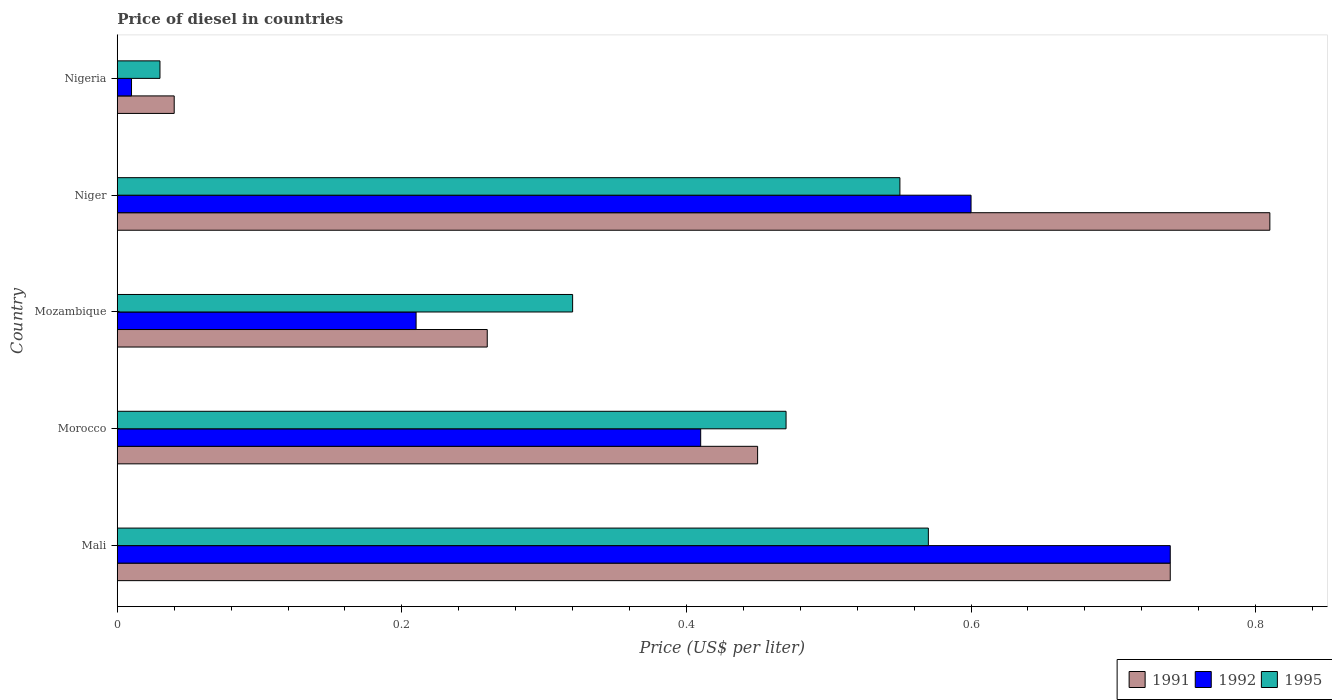How many different coloured bars are there?
Keep it short and to the point. 3. How many groups of bars are there?
Ensure brevity in your answer.  5. Are the number of bars per tick equal to the number of legend labels?
Give a very brief answer. Yes. How many bars are there on the 4th tick from the top?
Keep it short and to the point. 3. How many bars are there on the 4th tick from the bottom?
Keep it short and to the point. 3. What is the label of the 4th group of bars from the top?
Your response must be concise. Morocco. In how many cases, is the number of bars for a given country not equal to the number of legend labels?
Provide a succinct answer. 0. What is the price of diesel in 1992 in Niger?
Make the answer very short. 0.6. Across all countries, what is the maximum price of diesel in 1992?
Keep it short and to the point. 0.74. Across all countries, what is the minimum price of diesel in 1992?
Your answer should be very brief. 0.01. In which country was the price of diesel in 1991 maximum?
Your response must be concise. Niger. In which country was the price of diesel in 1995 minimum?
Offer a very short reply. Nigeria. What is the total price of diesel in 1995 in the graph?
Keep it short and to the point. 1.94. What is the difference between the price of diesel in 1991 in Mali and that in Mozambique?
Give a very brief answer. 0.48. What is the difference between the price of diesel in 1995 in Mozambique and the price of diesel in 1992 in Mali?
Keep it short and to the point. -0.42. What is the average price of diesel in 1992 per country?
Your answer should be compact. 0.39. What is the difference between the price of diesel in 1991 and price of diesel in 1995 in Morocco?
Offer a terse response. -0.02. What is the ratio of the price of diesel in 1991 in Morocco to that in Nigeria?
Keep it short and to the point. 11.25. Is the price of diesel in 1992 in Mali less than that in Morocco?
Keep it short and to the point. No. Is the difference between the price of diesel in 1991 in Mali and Mozambique greater than the difference between the price of diesel in 1995 in Mali and Mozambique?
Your response must be concise. Yes. What is the difference between the highest and the second highest price of diesel in 1991?
Your response must be concise. 0.07. What is the difference between the highest and the lowest price of diesel in 1991?
Provide a short and direct response. 0.77. Is the sum of the price of diesel in 1992 in Mozambique and Nigeria greater than the maximum price of diesel in 1991 across all countries?
Keep it short and to the point. No. What does the 3rd bar from the top in Mozambique represents?
Keep it short and to the point. 1991. Are all the bars in the graph horizontal?
Make the answer very short. Yes. How many countries are there in the graph?
Your answer should be compact. 5. Does the graph contain grids?
Keep it short and to the point. No. Where does the legend appear in the graph?
Keep it short and to the point. Bottom right. How many legend labels are there?
Provide a succinct answer. 3. What is the title of the graph?
Offer a very short reply. Price of diesel in countries. Does "1972" appear as one of the legend labels in the graph?
Your response must be concise. No. What is the label or title of the X-axis?
Offer a very short reply. Price (US$ per liter). What is the Price (US$ per liter) in 1991 in Mali?
Give a very brief answer. 0.74. What is the Price (US$ per liter) in 1992 in Mali?
Your answer should be very brief. 0.74. What is the Price (US$ per liter) of 1995 in Mali?
Your response must be concise. 0.57. What is the Price (US$ per liter) in 1991 in Morocco?
Ensure brevity in your answer.  0.45. What is the Price (US$ per liter) of 1992 in Morocco?
Give a very brief answer. 0.41. What is the Price (US$ per liter) in 1995 in Morocco?
Offer a terse response. 0.47. What is the Price (US$ per liter) in 1991 in Mozambique?
Offer a very short reply. 0.26. What is the Price (US$ per liter) in 1992 in Mozambique?
Your answer should be compact. 0.21. What is the Price (US$ per liter) in 1995 in Mozambique?
Give a very brief answer. 0.32. What is the Price (US$ per liter) of 1991 in Niger?
Make the answer very short. 0.81. What is the Price (US$ per liter) in 1995 in Niger?
Provide a short and direct response. 0.55. What is the Price (US$ per liter) in 1992 in Nigeria?
Your answer should be compact. 0.01. What is the Price (US$ per liter) of 1995 in Nigeria?
Your answer should be compact. 0.03. Across all countries, what is the maximum Price (US$ per liter) in 1991?
Keep it short and to the point. 0.81. Across all countries, what is the maximum Price (US$ per liter) of 1992?
Give a very brief answer. 0.74. Across all countries, what is the maximum Price (US$ per liter) in 1995?
Give a very brief answer. 0.57. Across all countries, what is the minimum Price (US$ per liter) of 1995?
Keep it short and to the point. 0.03. What is the total Price (US$ per liter) in 1991 in the graph?
Your answer should be very brief. 2.3. What is the total Price (US$ per liter) of 1992 in the graph?
Keep it short and to the point. 1.97. What is the total Price (US$ per liter) of 1995 in the graph?
Your response must be concise. 1.94. What is the difference between the Price (US$ per liter) of 1991 in Mali and that in Morocco?
Provide a succinct answer. 0.29. What is the difference between the Price (US$ per liter) in 1992 in Mali and that in Morocco?
Provide a succinct answer. 0.33. What is the difference between the Price (US$ per liter) of 1995 in Mali and that in Morocco?
Offer a terse response. 0.1. What is the difference between the Price (US$ per liter) of 1991 in Mali and that in Mozambique?
Offer a terse response. 0.48. What is the difference between the Price (US$ per liter) of 1992 in Mali and that in Mozambique?
Your answer should be very brief. 0.53. What is the difference between the Price (US$ per liter) of 1995 in Mali and that in Mozambique?
Provide a succinct answer. 0.25. What is the difference between the Price (US$ per liter) of 1991 in Mali and that in Niger?
Ensure brevity in your answer.  -0.07. What is the difference between the Price (US$ per liter) in 1992 in Mali and that in Niger?
Provide a short and direct response. 0.14. What is the difference between the Price (US$ per liter) in 1995 in Mali and that in Niger?
Offer a very short reply. 0.02. What is the difference between the Price (US$ per liter) in 1992 in Mali and that in Nigeria?
Keep it short and to the point. 0.73. What is the difference between the Price (US$ per liter) of 1995 in Mali and that in Nigeria?
Give a very brief answer. 0.54. What is the difference between the Price (US$ per liter) of 1991 in Morocco and that in Mozambique?
Your answer should be compact. 0.19. What is the difference between the Price (US$ per liter) in 1992 in Morocco and that in Mozambique?
Ensure brevity in your answer.  0.2. What is the difference between the Price (US$ per liter) in 1995 in Morocco and that in Mozambique?
Ensure brevity in your answer.  0.15. What is the difference between the Price (US$ per liter) of 1991 in Morocco and that in Niger?
Provide a succinct answer. -0.36. What is the difference between the Price (US$ per liter) of 1992 in Morocco and that in Niger?
Your response must be concise. -0.19. What is the difference between the Price (US$ per liter) in 1995 in Morocco and that in Niger?
Give a very brief answer. -0.08. What is the difference between the Price (US$ per liter) in 1991 in Morocco and that in Nigeria?
Keep it short and to the point. 0.41. What is the difference between the Price (US$ per liter) in 1992 in Morocco and that in Nigeria?
Offer a very short reply. 0.4. What is the difference between the Price (US$ per liter) of 1995 in Morocco and that in Nigeria?
Offer a terse response. 0.44. What is the difference between the Price (US$ per liter) in 1991 in Mozambique and that in Niger?
Ensure brevity in your answer.  -0.55. What is the difference between the Price (US$ per liter) of 1992 in Mozambique and that in Niger?
Offer a very short reply. -0.39. What is the difference between the Price (US$ per liter) of 1995 in Mozambique and that in Niger?
Your response must be concise. -0.23. What is the difference between the Price (US$ per liter) of 1991 in Mozambique and that in Nigeria?
Give a very brief answer. 0.22. What is the difference between the Price (US$ per liter) in 1995 in Mozambique and that in Nigeria?
Make the answer very short. 0.29. What is the difference between the Price (US$ per liter) of 1991 in Niger and that in Nigeria?
Give a very brief answer. 0.77. What is the difference between the Price (US$ per liter) of 1992 in Niger and that in Nigeria?
Your answer should be very brief. 0.59. What is the difference between the Price (US$ per liter) in 1995 in Niger and that in Nigeria?
Make the answer very short. 0.52. What is the difference between the Price (US$ per liter) of 1991 in Mali and the Price (US$ per liter) of 1992 in Morocco?
Provide a short and direct response. 0.33. What is the difference between the Price (US$ per liter) of 1991 in Mali and the Price (US$ per liter) of 1995 in Morocco?
Your answer should be compact. 0.27. What is the difference between the Price (US$ per liter) of 1992 in Mali and the Price (US$ per liter) of 1995 in Morocco?
Give a very brief answer. 0.27. What is the difference between the Price (US$ per liter) in 1991 in Mali and the Price (US$ per liter) in 1992 in Mozambique?
Your answer should be compact. 0.53. What is the difference between the Price (US$ per liter) of 1991 in Mali and the Price (US$ per liter) of 1995 in Mozambique?
Give a very brief answer. 0.42. What is the difference between the Price (US$ per liter) of 1992 in Mali and the Price (US$ per liter) of 1995 in Mozambique?
Keep it short and to the point. 0.42. What is the difference between the Price (US$ per liter) in 1991 in Mali and the Price (US$ per liter) in 1992 in Niger?
Give a very brief answer. 0.14. What is the difference between the Price (US$ per liter) in 1991 in Mali and the Price (US$ per liter) in 1995 in Niger?
Provide a short and direct response. 0.19. What is the difference between the Price (US$ per liter) of 1992 in Mali and the Price (US$ per liter) of 1995 in Niger?
Your answer should be very brief. 0.19. What is the difference between the Price (US$ per liter) of 1991 in Mali and the Price (US$ per liter) of 1992 in Nigeria?
Keep it short and to the point. 0.73. What is the difference between the Price (US$ per liter) in 1991 in Mali and the Price (US$ per liter) in 1995 in Nigeria?
Offer a very short reply. 0.71. What is the difference between the Price (US$ per liter) in 1992 in Mali and the Price (US$ per liter) in 1995 in Nigeria?
Offer a terse response. 0.71. What is the difference between the Price (US$ per liter) of 1991 in Morocco and the Price (US$ per liter) of 1992 in Mozambique?
Provide a short and direct response. 0.24. What is the difference between the Price (US$ per liter) of 1991 in Morocco and the Price (US$ per liter) of 1995 in Mozambique?
Ensure brevity in your answer.  0.13. What is the difference between the Price (US$ per liter) in 1992 in Morocco and the Price (US$ per liter) in 1995 in Mozambique?
Make the answer very short. 0.09. What is the difference between the Price (US$ per liter) in 1992 in Morocco and the Price (US$ per liter) in 1995 in Niger?
Ensure brevity in your answer.  -0.14. What is the difference between the Price (US$ per liter) in 1991 in Morocco and the Price (US$ per liter) in 1992 in Nigeria?
Offer a terse response. 0.44. What is the difference between the Price (US$ per liter) of 1991 in Morocco and the Price (US$ per liter) of 1995 in Nigeria?
Provide a short and direct response. 0.42. What is the difference between the Price (US$ per liter) of 1992 in Morocco and the Price (US$ per liter) of 1995 in Nigeria?
Offer a very short reply. 0.38. What is the difference between the Price (US$ per liter) in 1991 in Mozambique and the Price (US$ per liter) in 1992 in Niger?
Keep it short and to the point. -0.34. What is the difference between the Price (US$ per liter) in 1991 in Mozambique and the Price (US$ per liter) in 1995 in Niger?
Your answer should be very brief. -0.29. What is the difference between the Price (US$ per liter) in 1992 in Mozambique and the Price (US$ per liter) in 1995 in Niger?
Provide a short and direct response. -0.34. What is the difference between the Price (US$ per liter) of 1991 in Mozambique and the Price (US$ per liter) of 1995 in Nigeria?
Your answer should be compact. 0.23. What is the difference between the Price (US$ per liter) of 1992 in Mozambique and the Price (US$ per liter) of 1995 in Nigeria?
Your answer should be very brief. 0.18. What is the difference between the Price (US$ per liter) in 1991 in Niger and the Price (US$ per liter) in 1995 in Nigeria?
Make the answer very short. 0.78. What is the difference between the Price (US$ per liter) of 1992 in Niger and the Price (US$ per liter) of 1995 in Nigeria?
Make the answer very short. 0.57. What is the average Price (US$ per liter) of 1991 per country?
Your answer should be very brief. 0.46. What is the average Price (US$ per liter) in 1992 per country?
Your response must be concise. 0.39. What is the average Price (US$ per liter) of 1995 per country?
Your answer should be very brief. 0.39. What is the difference between the Price (US$ per liter) in 1991 and Price (US$ per liter) in 1992 in Mali?
Offer a terse response. 0. What is the difference between the Price (US$ per liter) of 1991 and Price (US$ per liter) of 1995 in Mali?
Give a very brief answer. 0.17. What is the difference between the Price (US$ per liter) of 1992 and Price (US$ per liter) of 1995 in Mali?
Provide a succinct answer. 0.17. What is the difference between the Price (US$ per liter) of 1991 and Price (US$ per liter) of 1992 in Morocco?
Provide a succinct answer. 0.04. What is the difference between the Price (US$ per liter) in 1991 and Price (US$ per liter) in 1995 in Morocco?
Provide a succinct answer. -0.02. What is the difference between the Price (US$ per liter) of 1992 and Price (US$ per liter) of 1995 in Morocco?
Provide a short and direct response. -0.06. What is the difference between the Price (US$ per liter) of 1991 and Price (US$ per liter) of 1995 in Mozambique?
Your response must be concise. -0.06. What is the difference between the Price (US$ per liter) of 1992 and Price (US$ per liter) of 1995 in Mozambique?
Provide a short and direct response. -0.11. What is the difference between the Price (US$ per liter) of 1991 and Price (US$ per liter) of 1992 in Niger?
Offer a terse response. 0.21. What is the difference between the Price (US$ per liter) in 1991 and Price (US$ per liter) in 1995 in Niger?
Your answer should be compact. 0.26. What is the difference between the Price (US$ per liter) of 1992 and Price (US$ per liter) of 1995 in Niger?
Offer a very short reply. 0.05. What is the difference between the Price (US$ per liter) in 1991 and Price (US$ per liter) in 1995 in Nigeria?
Give a very brief answer. 0.01. What is the difference between the Price (US$ per liter) in 1992 and Price (US$ per liter) in 1995 in Nigeria?
Provide a short and direct response. -0.02. What is the ratio of the Price (US$ per liter) of 1991 in Mali to that in Morocco?
Ensure brevity in your answer.  1.64. What is the ratio of the Price (US$ per liter) of 1992 in Mali to that in Morocco?
Your answer should be compact. 1.8. What is the ratio of the Price (US$ per liter) of 1995 in Mali to that in Morocco?
Offer a very short reply. 1.21. What is the ratio of the Price (US$ per liter) in 1991 in Mali to that in Mozambique?
Offer a terse response. 2.85. What is the ratio of the Price (US$ per liter) in 1992 in Mali to that in Mozambique?
Your answer should be compact. 3.52. What is the ratio of the Price (US$ per liter) of 1995 in Mali to that in Mozambique?
Your answer should be very brief. 1.78. What is the ratio of the Price (US$ per liter) of 1991 in Mali to that in Niger?
Your answer should be compact. 0.91. What is the ratio of the Price (US$ per liter) in 1992 in Mali to that in Niger?
Provide a short and direct response. 1.23. What is the ratio of the Price (US$ per liter) of 1995 in Mali to that in Niger?
Give a very brief answer. 1.04. What is the ratio of the Price (US$ per liter) of 1991 in Mali to that in Nigeria?
Your answer should be compact. 18.5. What is the ratio of the Price (US$ per liter) of 1992 in Mali to that in Nigeria?
Provide a short and direct response. 74. What is the ratio of the Price (US$ per liter) of 1991 in Morocco to that in Mozambique?
Provide a short and direct response. 1.73. What is the ratio of the Price (US$ per liter) in 1992 in Morocco to that in Mozambique?
Your response must be concise. 1.95. What is the ratio of the Price (US$ per liter) of 1995 in Morocco to that in Mozambique?
Offer a terse response. 1.47. What is the ratio of the Price (US$ per liter) in 1991 in Morocco to that in Niger?
Offer a very short reply. 0.56. What is the ratio of the Price (US$ per liter) in 1992 in Morocco to that in Niger?
Your answer should be very brief. 0.68. What is the ratio of the Price (US$ per liter) of 1995 in Morocco to that in Niger?
Offer a very short reply. 0.85. What is the ratio of the Price (US$ per liter) in 1991 in Morocco to that in Nigeria?
Provide a succinct answer. 11.25. What is the ratio of the Price (US$ per liter) of 1992 in Morocco to that in Nigeria?
Your response must be concise. 41. What is the ratio of the Price (US$ per liter) of 1995 in Morocco to that in Nigeria?
Provide a succinct answer. 15.67. What is the ratio of the Price (US$ per liter) in 1991 in Mozambique to that in Niger?
Provide a short and direct response. 0.32. What is the ratio of the Price (US$ per liter) of 1992 in Mozambique to that in Niger?
Offer a very short reply. 0.35. What is the ratio of the Price (US$ per liter) of 1995 in Mozambique to that in Niger?
Your answer should be compact. 0.58. What is the ratio of the Price (US$ per liter) of 1991 in Mozambique to that in Nigeria?
Provide a succinct answer. 6.5. What is the ratio of the Price (US$ per liter) of 1992 in Mozambique to that in Nigeria?
Offer a terse response. 21. What is the ratio of the Price (US$ per liter) of 1995 in Mozambique to that in Nigeria?
Ensure brevity in your answer.  10.67. What is the ratio of the Price (US$ per liter) in 1991 in Niger to that in Nigeria?
Make the answer very short. 20.25. What is the ratio of the Price (US$ per liter) of 1995 in Niger to that in Nigeria?
Ensure brevity in your answer.  18.33. What is the difference between the highest and the second highest Price (US$ per liter) in 1991?
Offer a terse response. 0.07. What is the difference between the highest and the second highest Price (US$ per liter) in 1992?
Your answer should be compact. 0.14. What is the difference between the highest and the lowest Price (US$ per liter) in 1991?
Give a very brief answer. 0.77. What is the difference between the highest and the lowest Price (US$ per liter) in 1992?
Your answer should be very brief. 0.73. What is the difference between the highest and the lowest Price (US$ per liter) of 1995?
Your answer should be very brief. 0.54. 